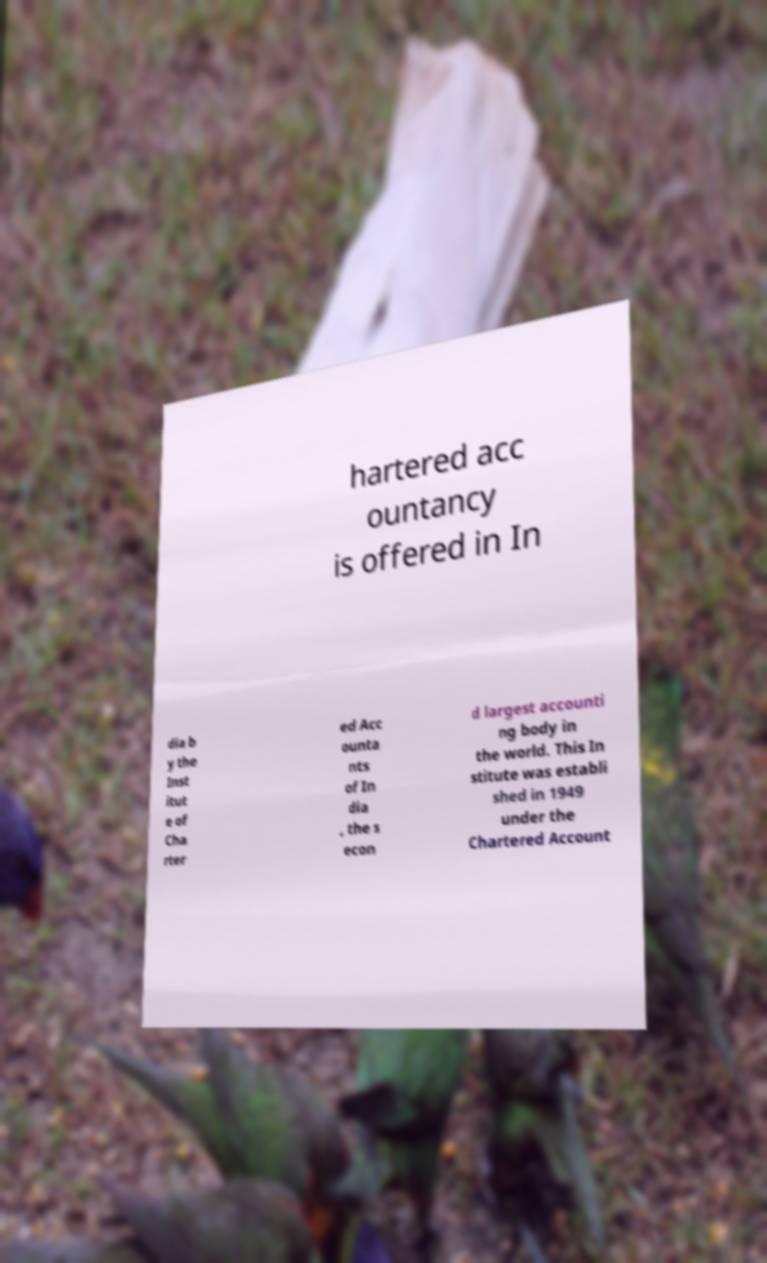What messages or text are displayed in this image? I need them in a readable, typed format. hartered acc ountancy is offered in In dia b y the Inst itut e of Cha rter ed Acc ounta nts of In dia , the s econ d largest accounti ng body in the world. This In stitute was establi shed in 1949 under the Chartered Account 